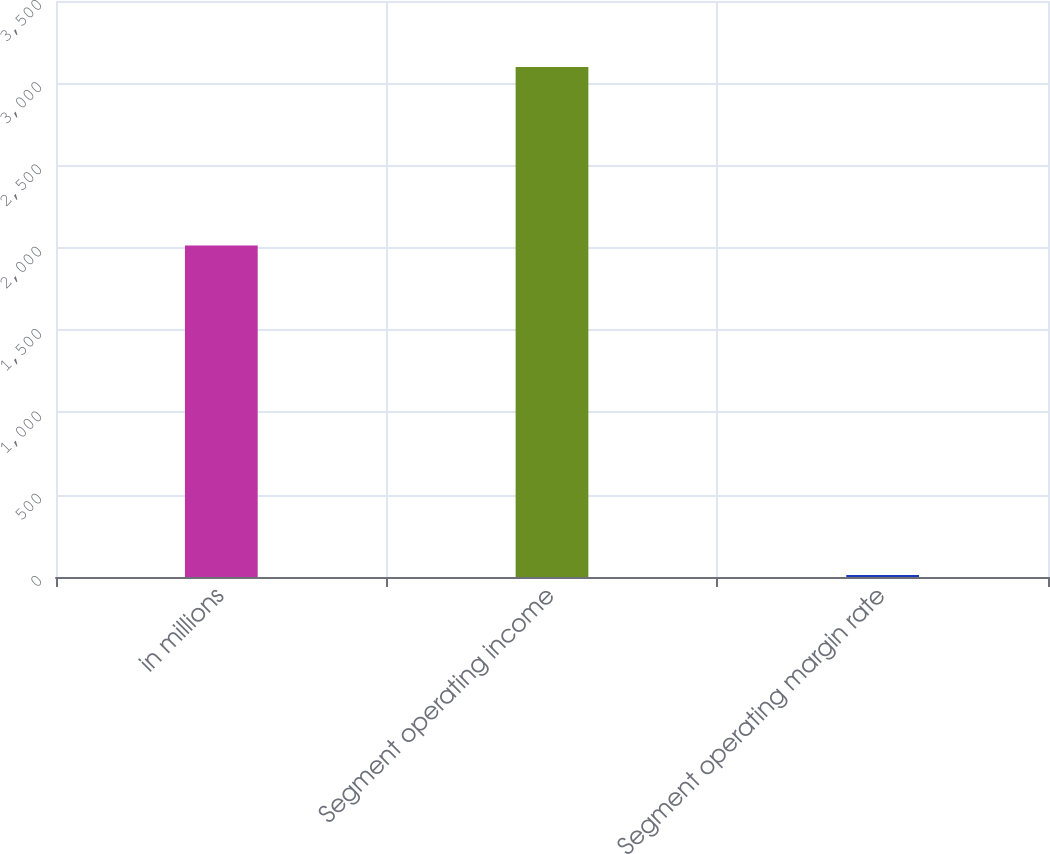<chart> <loc_0><loc_0><loc_500><loc_500><bar_chart><fcel>in millions<fcel>Segment operating income<fcel>Segment operating margin rate<nl><fcel>2014<fcel>3099<fcel>12.9<nl></chart> 